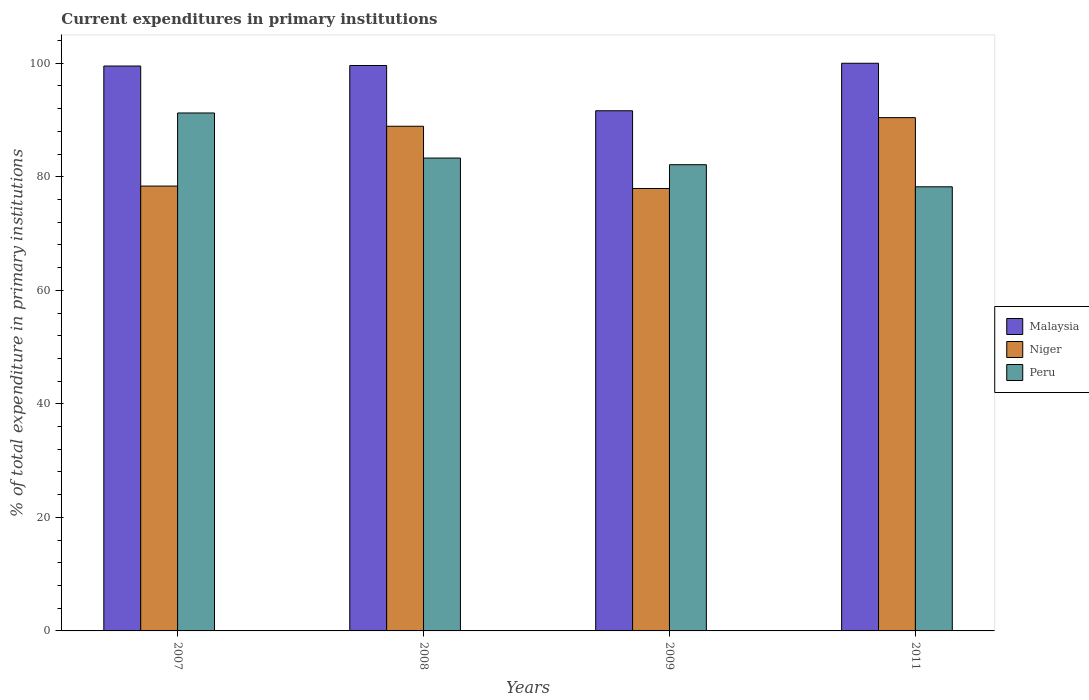In how many cases, is the number of bars for a given year not equal to the number of legend labels?
Provide a succinct answer. 0. What is the current expenditures in primary institutions in Niger in 2007?
Provide a succinct answer. 78.36. Across all years, what is the maximum current expenditures in primary institutions in Niger?
Offer a very short reply. 90.42. Across all years, what is the minimum current expenditures in primary institutions in Malaysia?
Ensure brevity in your answer.  91.63. In which year was the current expenditures in primary institutions in Niger maximum?
Your response must be concise. 2011. What is the total current expenditures in primary institutions in Peru in the graph?
Make the answer very short. 334.91. What is the difference between the current expenditures in primary institutions in Niger in 2007 and that in 2008?
Your answer should be very brief. -10.54. What is the difference between the current expenditures in primary institutions in Malaysia in 2007 and the current expenditures in primary institutions in Peru in 2008?
Ensure brevity in your answer.  16.21. What is the average current expenditures in primary institutions in Niger per year?
Give a very brief answer. 83.91. In the year 2007, what is the difference between the current expenditures in primary institutions in Niger and current expenditures in primary institutions in Peru?
Offer a very short reply. -12.88. In how many years, is the current expenditures in primary institutions in Malaysia greater than 28 %?
Offer a terse response. 4. What is the ratio of the current expenditures in primary institutions in Malaysia in 2008 to that in 2009?
Offer a terse response. 1.09. Is the difference between the current expenditures in primary institutions in Niger in 2009 and 2011 greater than the difference between the current expenditures in primary institutions in Peru in 2009 and 2011?
Your answer should be compact. No. What is the difference between the highest and the second highest current expenditures in primary institutions in Niger?
Make the answer very short. 1.52. What is the difference between the highest and the lowest current expenditures in primary institutions in Malaysia?
Your answer should be very brief. 8.37. In how many years, is the current expenditures in primary institutions in Malaysia greater than the average current expenditures in primary institutions in Malaysia taken over all years?
Give a very brief answer. 3. What does the 2nd bar from the left in 2011 represents?
Your answer should be very brief. Niger. What does the 1st bar from the right in 2009 represents?
Keep it short and to the point. Peru. What is the difference between two consecutive major ticks on the Y-axis?
Keep it short and to the point. 20. Are the values on the major ticks of Y-axis written in scientific E-notation?
Ensure brevity in your answer.  No. How many legend labels are there?
Keep it short and to the point. 3. What is the title of the graph?
Provide a succinct answer. Current expenditures in primary institutions. Does "Belarus" appear as one of the legend labels in the graph?
Provide a short and direct response. No. What is the label or title of the Y-axis?
Offer a terse response. % of total expenditure in primary institutions. What is the % of total expenditure in primary institutions in Malaysia in 2007?
Ensure brevity in your answer.  99.51. What is the % of total expenditure in primary institutions of Niger in 2007?
Make the answer very short. 78.36. What is the % of total expenditure in primary institutions in Peru in 2007?
Ensure brevity in your answer.  91.24. What is the % of total expenditure in primary institutions in Malaysia in 2008?
Provide a short and direct response. 99.61. What is the % of total expenditure in primary institutions of Niger in 2008?
Ensure brevity in your answer.  88.9. What is the % of total expenditure in primary institutions in Peru in 2008?
Make the answer very short. 83.3. What is the % of total expenditure in primary institutions in Malaysia in 2009?
Your response must be concise. 91.63. What is the % of total expenditure in primary institutions in Niger in 2009?
Give a very brief answer. 77.94. What is the % of total expenditure in primary institutions of Peru in 2009?
Your answer should be very brief. 82.13. What is the % of total expenditure in primary institutions in Malaysia in 2011?
Offer a terse response. 100. What is the % of total expenditure in primary institutions of Niger in 2011?
Keep it short and to the point. 90.42. What is the % of total expenditure in primary institutions of Peru in 2011?
Your answer should be compact. 78.24. Across all years, what is the maximum % of total expenditure in primary institutions in Niger?
Your answer should be compact. 90.42. Across all years, what is the maximum % of total expenditure in primary institutions in Peru?
Ensure brevity in your answer.  91.24. Across all years, what is the minimum % of total expenditure in primary institutions of Malaysia?
Make the answer very short. 91.63. Across all years, what is the minimum % of total expenditure in primary institutions of Niger?
Give a very brief answer. 77.94. Across all years, what is the minimum % of total expenditure in primary institutions of Peru?
Provide a succinct answer. 78.24. What is the total % of total expenditure in primary institutions of Malaysia in the graph?
Your answer should be very brief. 390.75. What is the total % of total expenditure in primary institutions in Niger in the graph?
Your response must be concise. 335.63. What is the total % of total expenditure in primary institutions in Peru in the graph?
Make the answer very short. 334.91. What is the difference between the % of total expenditure in primary institutions of Malaysia in 2007 and that in 2008?
Make the answer very short. -0.09. What is the difference between the % of total expenditure in primary institutions in Niger in 2007 and that in 2008?
Your response must be concise. -10.54. What is the difference between the % of total expenditure in primary institutions in Peru in 2007 and that in 2008?
Offer a terse response. 7.94. What is the difference between the % of total expenditure in primary institutions of Malaysia in 2007 and that in 2009?
Your answer should be compact. 7.88. What is the difference between the % of total expenditure in primary institutions of Niger in 2007 and that in 2009?
Ensure brevity in your answer.  0.42. What is the difference between the % of total expenditure in primary institutions of Peru in 2007 and that in 2009?
Your answer should be very brief. 9.11. What is the difference between the % of total expenditure in primary institutions in Malaysia in 2007 and that in 2011?
Offer a terse response. -0.49. What is the difference between the % of total expenditure in primary institutions in Niger in 2007 and that in 2011?
Provide a short and direct response. -12.06. What is the difference between the % of total expenditure in primary institutions of Peru in 2007 and that in 2011?
Your response must be concise. 13.01. What is the difference between the % of total expenditure in primary institutions of Malaysia in 2008 and that in 2009?
Ensure brevity in your answer.  7.97. What is the difference between the % of total expenditure in primary institutions in Niger in 2008 and that in 2009?
Your answer should be compact. 10.96. What is the difference between the % of total expenditure in primary institutions of Peru in 2008 and that in 2009?
Ensure brevity in your answer.  1.17. What is the difference between the % of total expenditure in primary institutions of Malaysia in 2008 and that in 2011?
Your answer should be very brief. -0.39. What is the difference between the % of total expenditure in primary institutions of Niger in 2008 and that in 2011?
Make the answer very short. -1.52. What is the difference between the % of total expenditure in primary institutions of Peru in 2008 and that in 2011?
Provide a succinct answer. 5.07. What is the difference between the % of total expenditure in primary institutions in Malaysia in 2009 and that in 2011?
Your answer should be compact. -8.37. What is the difference between the % of total expenditure in primary institutions of Niger in 2009 and that in 2011?
Keep it short and to the point. -12.48. What is the difference between the % of total expenditure in primary institutions in Peru in 2009 and that in 2011?
Provide a short and direct response. 3.89. What is the difference between the % of total expenditure in primary institutions of Malaysia in 2007 and the % of total expenditure in primary institutions of Niger in 2008?
Give a very brief answer. 10.61. What is the difference between the % of total expenditure in primary institutions of Malaysia in 2007 and the % of total expenditure in primary institutions of Peru in 2008?
Your response must be concise. 16.21. What is the difference between the % of total expenditure in primary institutions of Niger in 2007 and the % of total expenditure in primary institutions of Peru in 2008?
Offer a very short reply. -4.94. What is the difference between the % of total expenditure in primary institutions of Malaysia in 2007 and the % of total expenditure in primary institutions of Niger in 2009?
Your response must be concise. 21.57. What is the difference between the % of total expenditure in primary institutions in Malaysia in 2007 and the % of total expenditure in primary institutions in Peru in 2009?
Provide a short and direct response. 17.38. What is the difference between the % of total expenditure in primary institutions of Niger in 2007 and the % of total expenditure in primary institutions of Peru in 2009?
Provide a short and direct response. -3.76. What is the difference between the % of total expenditure in primary institutions in Malaysia in 2007 and the % of total expenditure in primary institutions in Niger in 2011?
Make the answer very short. 9.09. What is the difference between the % of total expenditure in primary institutions in Malaysia in 2007 and the % of total expenditure in primary institutions in Peru in 2011?
Ensure brevity in your answer.  21.28. What is the difference between the % of total expenditure in primary institutions in Niger in 2007 and the % of total expenditure in primary institutions in Peru in 2011?
Make the answer very short. 0.13. What is the difference between the % of total expenditure in primary institutions in Malaysia in 2008 and the % of total expenditure in primary institutions in Niger in 2009?
Give a very brief answer. 21.67. What is the difference between the % of total expenditure in primary institutions in Malaysia in 2008 and the % of total expenditure in primary institutions in Peru in 2009?
Your answer should be very brief. 17.48. What is the difference between the % of total expenditure in primary institutions in Niger in 2008 and the % of total expenditure in primary institutions in Peru in 2009?
Give a very brief answer. 6.77. What is the difference between the % of total expenditure in primary institutions in Malaysia in 2008 and the % of total expenditure in primary institutions in Niger in 2011?
Your answer should be very brief. 9.19. What is the difference between the % of total expenditure in primary institutions in Malaysia in 2008 and the % of total expenditure in primary institutions in Peru in 2011?
Give a very brief answer. 21.37. What is the difference between the % of total expenditure in primary institutions in Niger in 2008 and the % of total expenditure in primary institutions in Peru in 2011?
Make the answer very short. 10.67. What is the difference between the % of total expenditure in primary institutions of Malaysia in 2009 and the % of total expenditure in primary institutions of Niger in 2011?
Offer a terse response. 1.21. What is the difference between the % of total expenditure in primary institutions of Malaysia in 2009 and the % of total expenditure in primary institutions of Peru in 2011?
Make the answer very short. 13.4. What is the difference between the % of total expenditure in primary institutions in Niger in 2009 and the % of total expenditure in primary institutions in Peru in 2011?
Give a very brief answer. -0.3. What is the average % of total expenditure in primary institutions in Malaysia per year?
Keep it short and to the point. 97.69. What is the average % of total expenditure in primary institutions of Niger per year?
Make the answer very short. 83.91. What is the average % of total expenditure in primary institutions of Peru per year?
Your response must be concise. 83.73. In the year 2007, what is the difference between the % of total expenditure in primary institutions in Malaysia and % of total expenditure in primary institutions in Niger?
Give a very brief answer. 21.15. In the year 2007, what is the difference between the % of total expenditure in primary institutions of Malaysia and % of total expenditure in primary institutions of Peru?
Give a very brief answer. 8.27. In the year 2007, what is the difference between the % of total expenditure in primary institutions of Niger and % of total expenditure in primary institutions of Peru?
Give a very brief answer. -12.88. In the year 2008, what is the difference between the % of total expenditure in primary institutions of Malaysia and % of total expenditure in primary institutions of Niger?
Make the answer very short. 10.7. In the year 2008, what is the difference between the % of total expenditure in primary institutions in Malaysia and % of total expenditure in primary institutions in Peru?
Offer a very short reply. 16.3. In the year 2008, what is the difference between the % of total expenditure in primary institutions of Niger and % of total expenditure in primary institutions of Peru?
Offer a very short reply. 5.6. In the year 2009, what is the difference between the % of total expenditure in primary institutions of Malaysia and % of total expenditure in primary institutions of Niger?
Give a very brief answer. 13.69. In the year 2009, what is the difference between the % of total expenditure in primary institutions of Malaysia and % of total expenditure in primary institutions of Peru?
Offer a very short reply. 9.5. In the year 2009, what is the difference between the % of total expenditure in primary institutions in Niger and % of total expenditure in primary institutions in Peru?
Provide a succinct answer. -4.19. In the year 2011, what is the difference between the % of total expenditure in primary institutions in Malaysia and % of total expenditure in primary institutions in Niger?
Provide a succinct answer. 9.58. In the year 2011, what is the difference between the % of total expenditure in primary institutions in Malaysia and % of total expenditure in primary institutions in Peru?
Give a very brief answer. 21.76. In the year 2011, what is the difference between the % of total expenditure in primary institutions of Niger and % of total expenditure in primary institutions of Peru?
Provide a succinct answer. 12.18. What is the ratio of the % of total expenditure in primary institutions in Niger in 2007 to that in 2008?
Your answer should be very brief. 0.88. What is the ratio of the % of total expenditure in primary institutions in Peru in 2007 to that in 2008?
Your answer should be compact. 1.1. What is the ratio of the % of total expenditure in primary institutions in Malaysia in 2007 to that in 2009?
Ensure brevity in your answer.  1.09. What is the ratio of the % of total expenditure in primary institutions in Niger in 2007 to that in 2009?
Your answer should be very brief. 1.01. What is the ratio of the % of total expenditure in primary institutions of Peru in 2007 to that in 2009?
Provide a succinct answer. 1.11. What is the ratio of the % of total expenditure in primary institutions of Malaysia in 2007 to that in 2011?
Provide a short and direct response. 1. What is the ratio of the % of total expenditure in primary institutions of Niger in 2007 to that in 2011?
Your answer should be compact. 0.87. What is the ratio of the % of total expenditure in primary institutions in Peru in 2007 to that in 2011?
Make the answer very short. 1.17. What is the ratio of the % of total expenditure in primary institutions in Malaysia in 2008 to that in 2009?
Ensure brevity in your answer.  1.09. What is the ratio of the % of total expenditure in primary institutions in Niger in 2008 to that in 2009?
Provide a succinct answer. 1.14. What is the ratio of the % of total expenditure in primary institutions of Peru in 2008 to that in 2009?
Offer a terse response. 1.01. What is the ratio of the % of total expenditure in primary institutions in Malaysia in 2008 to that in 2011?
Your answer should be compact. 1. What is the ratio of the % of total expenditure in primary institutions of Niger in 2008 to that in 2011?
Offer a terse response. 0.98. What is the ratio of the % of total expenditure in primary institutions in Peru in 2008 to that in 2011?
Make the answer very short. 1.06. What is the ratio of the % of total expenditure in primary institutions in Malaysia in 2009 to that in 2011?
Make the answer very short. 0.92. What is the ratio of the % of total expenditure in primary institutions in Niger in 2009 to that in 2011?
Your answer should be compact. 0.86. What is the ratio of the % of total expenditure in primary institutions in Peru in 2009 to that in 2011?
Your response must be concise. 1.05. What is the difference between the highest and the second highest % of total expenditure in primary institutions in Malaysia?
Your answer should be compact. 0.39. What is the difference between the highest and the second highest % of total expenditure in primary institutions of Niger?
Make the answer very short. 1.52. What is the difference between the highest and the second highest % of total expenditure in primary institutions of Peru?
Your answer should be very brief. 7.94. What is the difference between the highest and the lowest % of total expenditure in primary institutions in Malaysia?
Offer a very short reply. 8.37. What is the difference between the highest and the lowest % of total expenditure in primary institutions in Niger?
Provide a succinct answer. 12.48. What is the difference between the highest and the lowest % of total expenditure in primary institutions of Peru?
Make the answer very short. 13.01. 